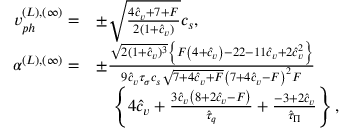<formula> <loc_0><loc_0><loc_500><loc_500>\begin{array} { r l } { v _ { p h } ^ { ( L ) , ( \infty ) } = } & { \pm \sqrt { \frac { 4 { \hat { c } _ { v } } + 7 + F } { 2 ( 1 + \hat { c } _ { v } ) } } c _ { s } , } \\ { \alpha ^ { ( L ) , ( \infty ) } = } & { \pm \frac { \sqrt { 2 ( 1 + { \hat { c } _ { v } } ) ^ { 3 } } \left \{ F \left ( 4 + { \hat { c } _ { v } } \right ) - 2 2 - 1 1 { \hat { c } _ { v } } + 2 { \hat { c } _ { v } } ^ { 2 } \right \} } { 9 \hat { c } _ { v } \tau _ { \sigma } c _ { s } \sqrt { 7 + 4 { \hat { c } _ { v } } + F } \left ( 7 + 4 { \hat { c } _ { v } } - F \right ) ^ { 2 } F } } \\ & { \quad \left \{ 4 { \hat { c } _ { v } } + \frac { 3 { \hat { c } _ { v } } \left ( 8 + 2 { \hat { c } _ { v } } - F \right ) } { \hat { \tau } _ { q } } + \frac { - 3 + 2 { \hat { c } _ { v } } } { \hat { \tau } _ { \Pi } } \right \} , } \end{array}</formula> 